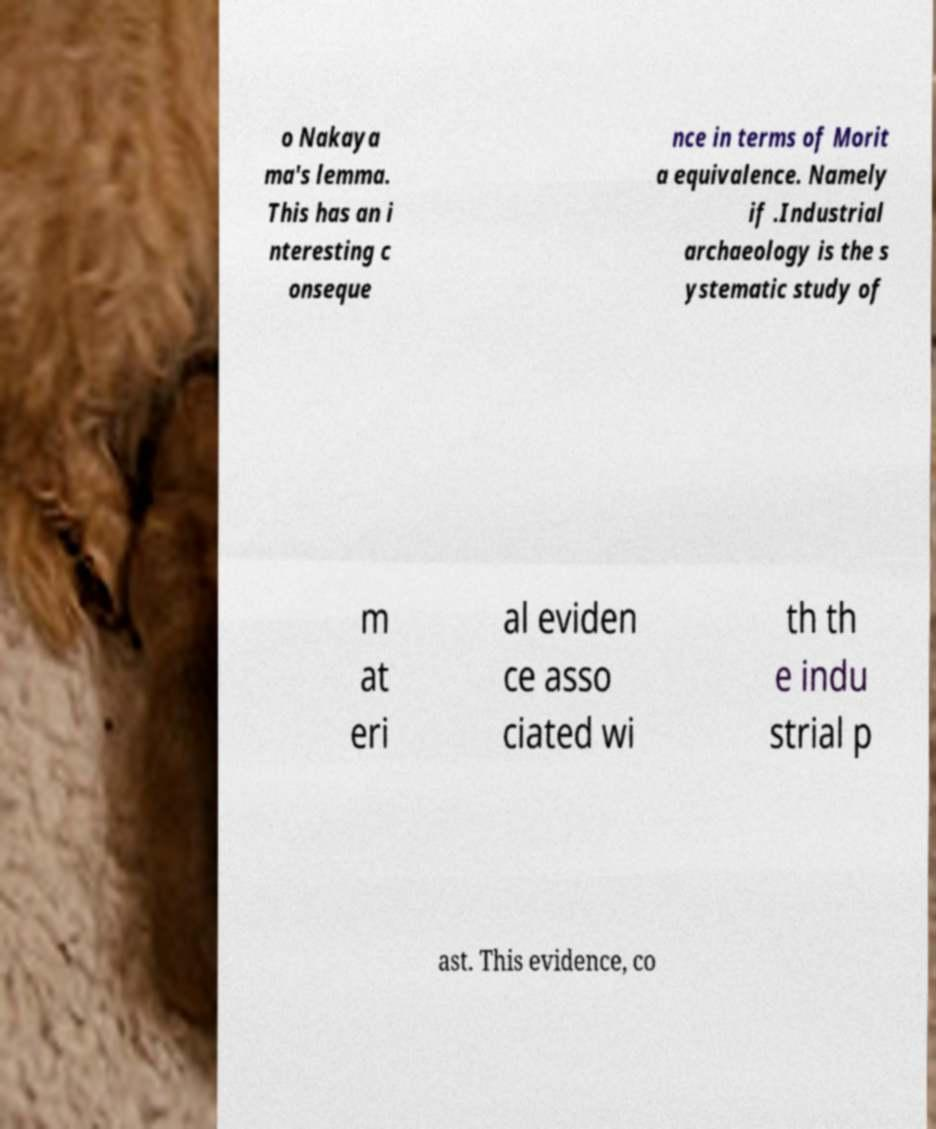Please identify and transcribe the text found in this image. o Nakaya ma's lemma. This has an i nteresting c onseque nce in terms of Morit a equivalence. Namely if .Industrial archaeology is the s ystematic study of m at eri al eviden ce asso ciated wi th th e indu strial p ast. This evidence, co 